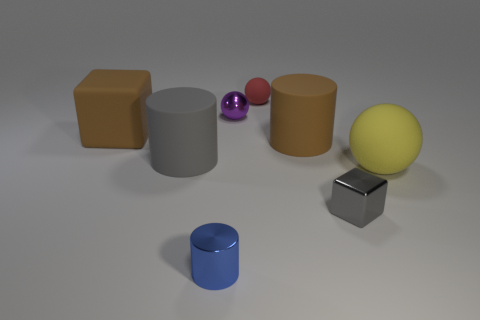Add 1 small metallic things. How many objects exist? 9 Subtract all spheres. How many objects are left? 5 Subtract all tiny purple spheres. Subtract all large gray matte cylinders. How many objects are left? 6 Add 4 big brown matte cylinders. How many big brown matte cylinders are left? 5 Add 8 tiny cylinders. How many tiny cylinders exist? 9 Subtract 0 cyan cylinders. How many objects are left? 8 